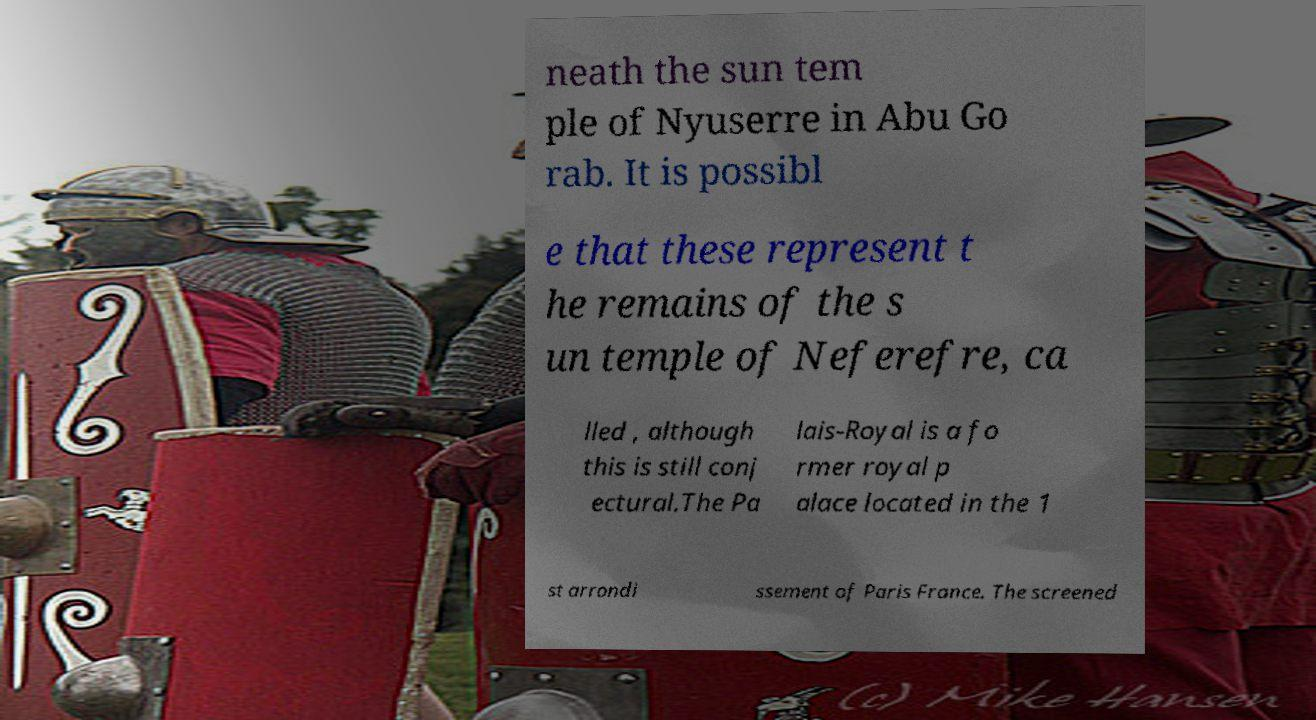What messages or text are displayed in this image? I need them in a readable, typed format. neath the sun tem ple of Nyuserre in Abu Go rab. It is possibl e that these represent t he remains of the s un temple of Neferefre, ca lled , although this is still conj ectural.The Pa lais-Royal is a fo rmer royal p alace located in the 1 st arrondi ssement of Paris France. The screened 